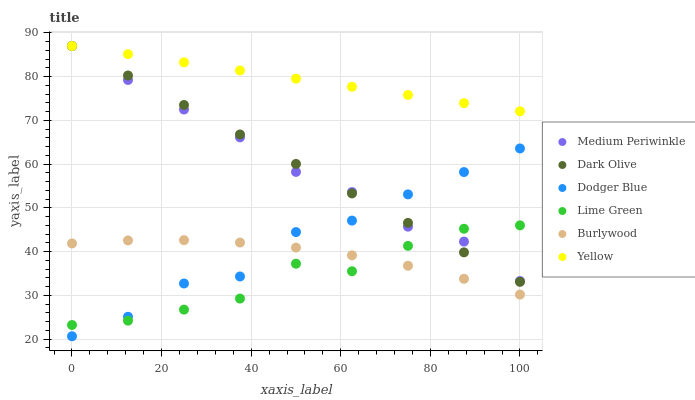Does Lime Green have the minimum area under the curve?
Answer yes or no. Yes. Does Yellow have the maximum area under the curve?
Answer yes or no. Yes. Does Dark Olive have the minimum area under the curve?
Answer yes or no. No. Does Dark Olive have the maximum area under the curve?
Answer yes or no. No. Is Yellow the smoothest?
Answer yes or no. Yes. Is Dodger Blue the roughest?
Answer yes or no. Yes. Is Dark Olive the smoothest?
Answer yes or no. No. Is Dark Olive the roughest?
Answer yes or no. No. Does Dodger Blue have the lowest value?
Answer yes or no. Yes. Does Dark Olive have the lowest value?
Answer yes or no. No. Does Yellow have the highest value?
Answer yes or no. Yes. Does Dodger Blue have the highest value?
Answer yes or no. No. Is Lime Green less than Yellow?
Answer yes or no. Yes. Is Dark Olive greater than Burlywood?
Answer yes or no. Yes. Does Medium Periwinkle intersect Dark Olive?
Answer yes or no. Yes. Is Medium Periwinkle less than Dark Olive?
Answer yes or no. No. Is Medium Periwinkle greater than Dark Olive?
Answer yes or no. No. Does Lime Green intersect Yellow?
Answer yes or no. No. 